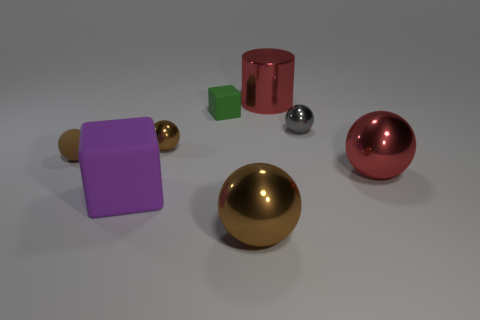How many gray cylinders have the same size as the matte sphere?
Make the answer very short. 0. What number of small things are either brown matte balls or spheres?
Provide a succinct answer. 3. Is there a large red shiny cylinder?
Ensure brevity in your answer.  Yes. Are there more large shiny cylinders left of the purple rubber object than small rubber cubes that are behind the red metallic cylinder?
Your response must be concise. No. What is the color of the large shiny ball behind the big metallic sphere in front of the purple block?
Offer a very short reply. Red. Are there any tiny objects of the same color as the small rubber cube?
Your response must be concise. No. How big is the cube to the left of the cube that is behind the brown metal object that is left of the large brown thing?
Your answer should be very brief. Large. What is the shape of the tiny brown metallic object?
Give a very brief answer. Sphere. What size is the ball that is the same color as the large metallic cylinder?
Offer a terse response. Large. What number of tiny things are left of the cube that is behind the tiny matte ball?
Offer a terse response. 2. 